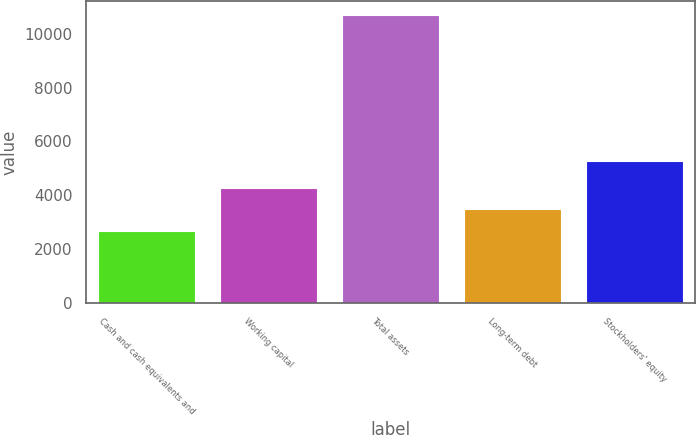Convert chart. <chart><loc_0><loc_0><loc_500><loc_500><bar_chart><fcel>Cash and cash equivalents and<fcel>Working capital<fcel>Total assets<fcel>Long-term debt<fcel>Stockholders' equity<nl><fcel>2675<fcel>4277.2<fcel>10686<fcel>3476.1<fcel>5286<nl></chart> 